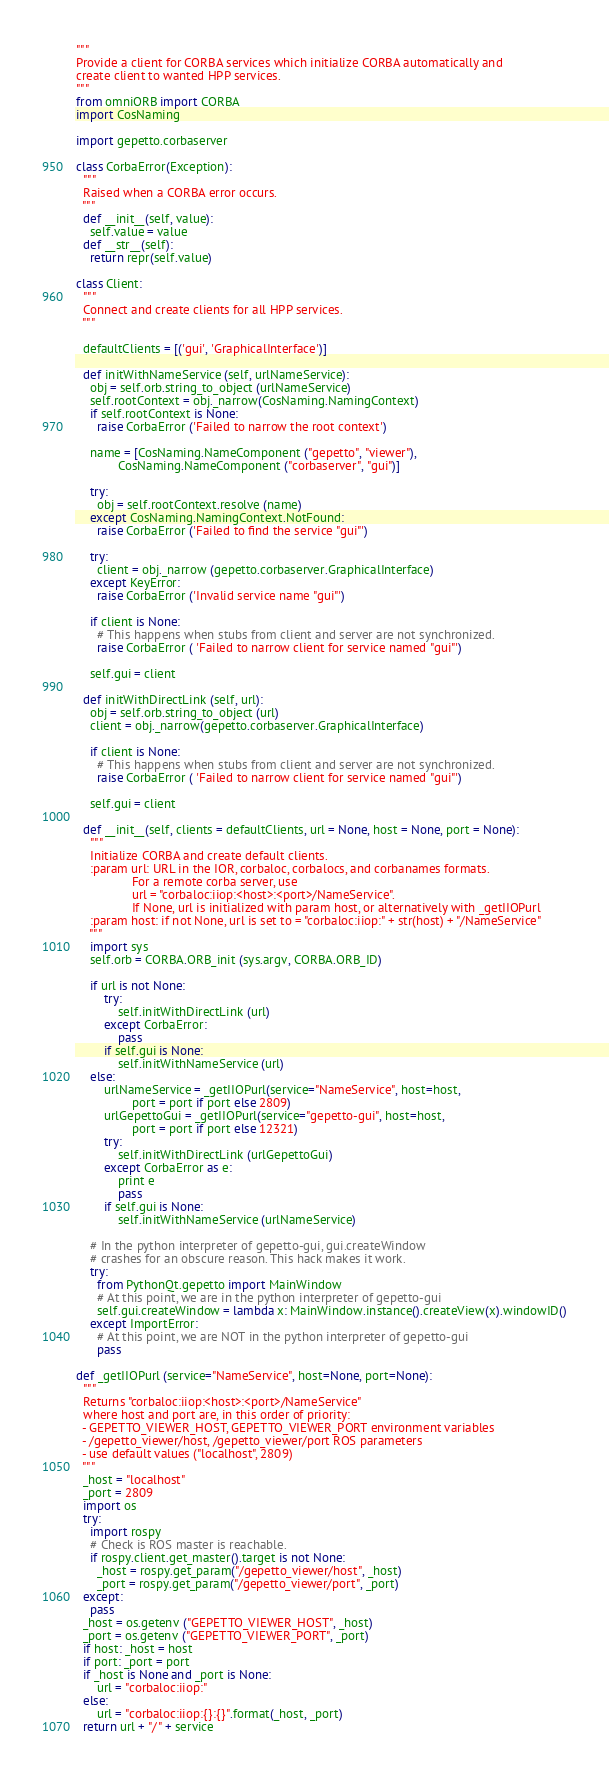Convert code to text. <code><loc_0><loc_0><loc_500><loc_500><_Python_>"""
Provide a client for CORBA services which initialize CORBA automatically and
create client to wanted HPP services.
"""
from omniORB import CORBA
import CosNaming

import gepetto.corbaserver

class CorbaError(Exception):
  """
  Raised when a CORBA error occurs.
  """
  def __init__(self, value):
    self.value = value
  def __str__(self):
    return repr(self.value)

class Client:
  """
  Connect and create clients for all HPP services.
  """

  defaultClients = [('gui', 'GraphicalInterface')]

  def initWithNameService (self, urlNameService):
    obj = self.orb.string_to_object (urlNameService)
    self.rootContext = obj._narrow(CosNaming.NamingContext)
    if self.rootContext is None:
      raise CorbaError ('Failed to narrow the root context')

    name = [CosNaming.NameComponent ("gepetto", "viewer"),
            CosNaming.NameComponent ("corbaserver", "gui")]

    try:
      obj = self.rootContext.resolve (name)
    except CosNaming.NamingContext.NotFound:
      raise CorbaError ('Failed to find the service "gui"')

    try:
      client = obj._narrow (gepetto.corbaserver.GraphicalInterface)
    except KeyError:
      raise CorbaError ('Invalid service name "gui"')

    if client is None:
      # This happens when stubs from client and server are not synchronized.
      raise CorbaError ( 'Failed to narrow client for service named "gui"')

    self.gui = client

  def initWithDirectLink (self, url):
    obj = self.orb.string_to_object (url)
    client = obj._narrow(gepetto.corbaserver.GraphicalInterface)

    if client is None:
      # This happens when stubs from client and server are not synchronized.
      raise CorbaError ( 'Failed to narrow client for service named "gui"')

    self.gui = client

  def __init__(self, clients = defaultClients, url = None, host = None, port = None):
    """
    Initialize CORBA and create default clients.
    :param url: URL in the IOR, corbaloc, corbalocs, and corbanames formats.
                For a remote corba server, use
                url = "corbaloc:iiop:<host>:<port>/NameService".
                If None, url is initialized with param host, or alternatively with _getIIOPurl
    :param host: if not None, url is set to = "corbaloc:iiop:" + str(host) + "/NameService"
    """
    import sys
    self.orb = CORBA.ORB_init (sys.argv, CORBA.ORB_ID)

    if url is not None:
        try:
            self.initWithDirectLink (url)
        except CorbaError:
            pass
        if self.gui is None:
            self.initWithNameService (url)
    else:
        urlNameService = _getIIOPurl(service="NameService", host=host,
                port = port if port else 2809)
        urlGepettoGui = _getIIOPurl(service="gepetto-gui", host=host,
                port = port if port else 12321)
        try:
            self.initWithDirectLink (urlGepettoGui)
        except CorbaError as e:
            print e
            pass
        if self.gui is None:
            self.initWithNameService (urlNameService)

    # In the python interpreter of gepetto-gui, gui.createWindow
    # crashes for an obscure reason. This hack makes it work.
    try:
      from PythonQt.gepetto import MainWindow
      # At this point, we are in the python interpreter of gepetto-gui
      self.gui.createWindow = lambda x: MainWindow.instance().createView(x).windowID()
    except ImportError:
      # At this point, we are NOT in the python interpreter of gepetto-gui
      pass

def _getIIOPurl (service="NameService", host=None, port=None):
  """
  Returns "corbaloc:iiop:<host>:<port>/NameService"
  where host and port are, in this order of priority:
  - GEPETTO_VIEWER_HOST, GEPETTO_VIEWER_PORT environment variables
  - /gepetto_viewer/host, /gepetto_viewer/port ROS parameters
  - use default values ("localhost", 2809)
  """
  _host = "localhost"
  _port = 2809
  import os
  try:
    import rospy
    # Check is ROS master is reachable.
    if rospy.client.get_master().target is not None:
      _host = rospy.get_param("/gepetto_viewer/host", _host)
      _port = rospy.get_param("/gepetto_viewer/port", _port)
  except:
    pass
  _host = os.getenv ("GEPETTO_VIEWER_HOST", _host)
  _port = os.getenv ("GEPETTO_VIEWER_PORT", _port)
  if host: _host = host
  if port: _port = port
  if _host is None and _port is None:
      url = "corbaloc:iiop:"
  else:
      url = "corbaloc:iiop:{}:{}".format(_host, _port)
  return url + "/" + service
</code> 